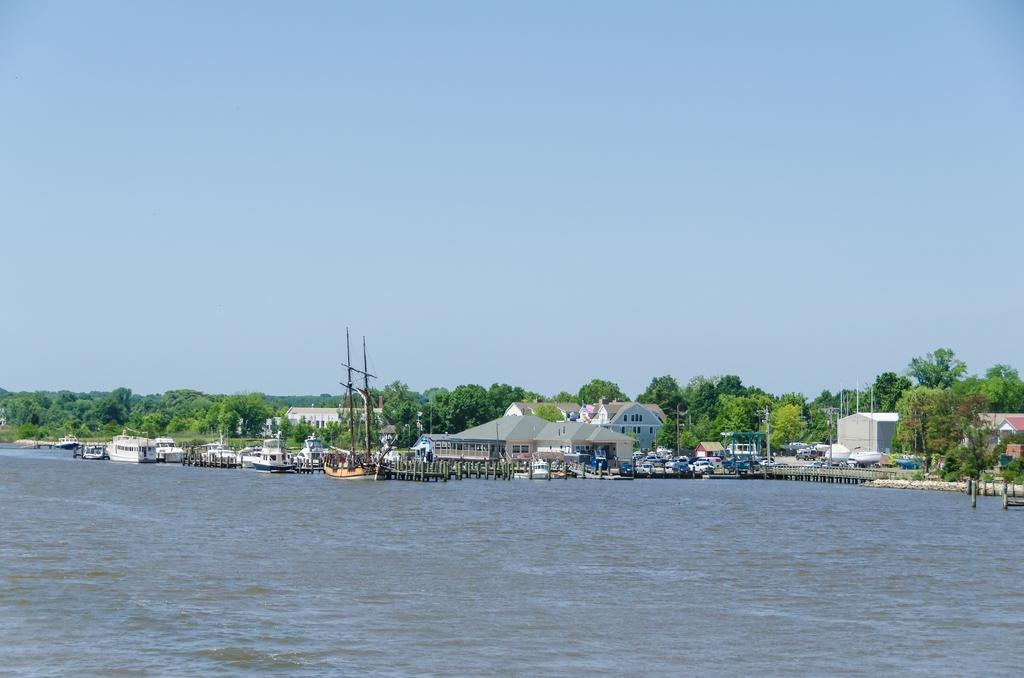In one or two sentences, can you explain what this image depicts? In this picture there is water at the bottom side of the image and there are houses, trees, and poles in the center of the image and there is a ship on the water in the image, there is sky at the top side of the image. 